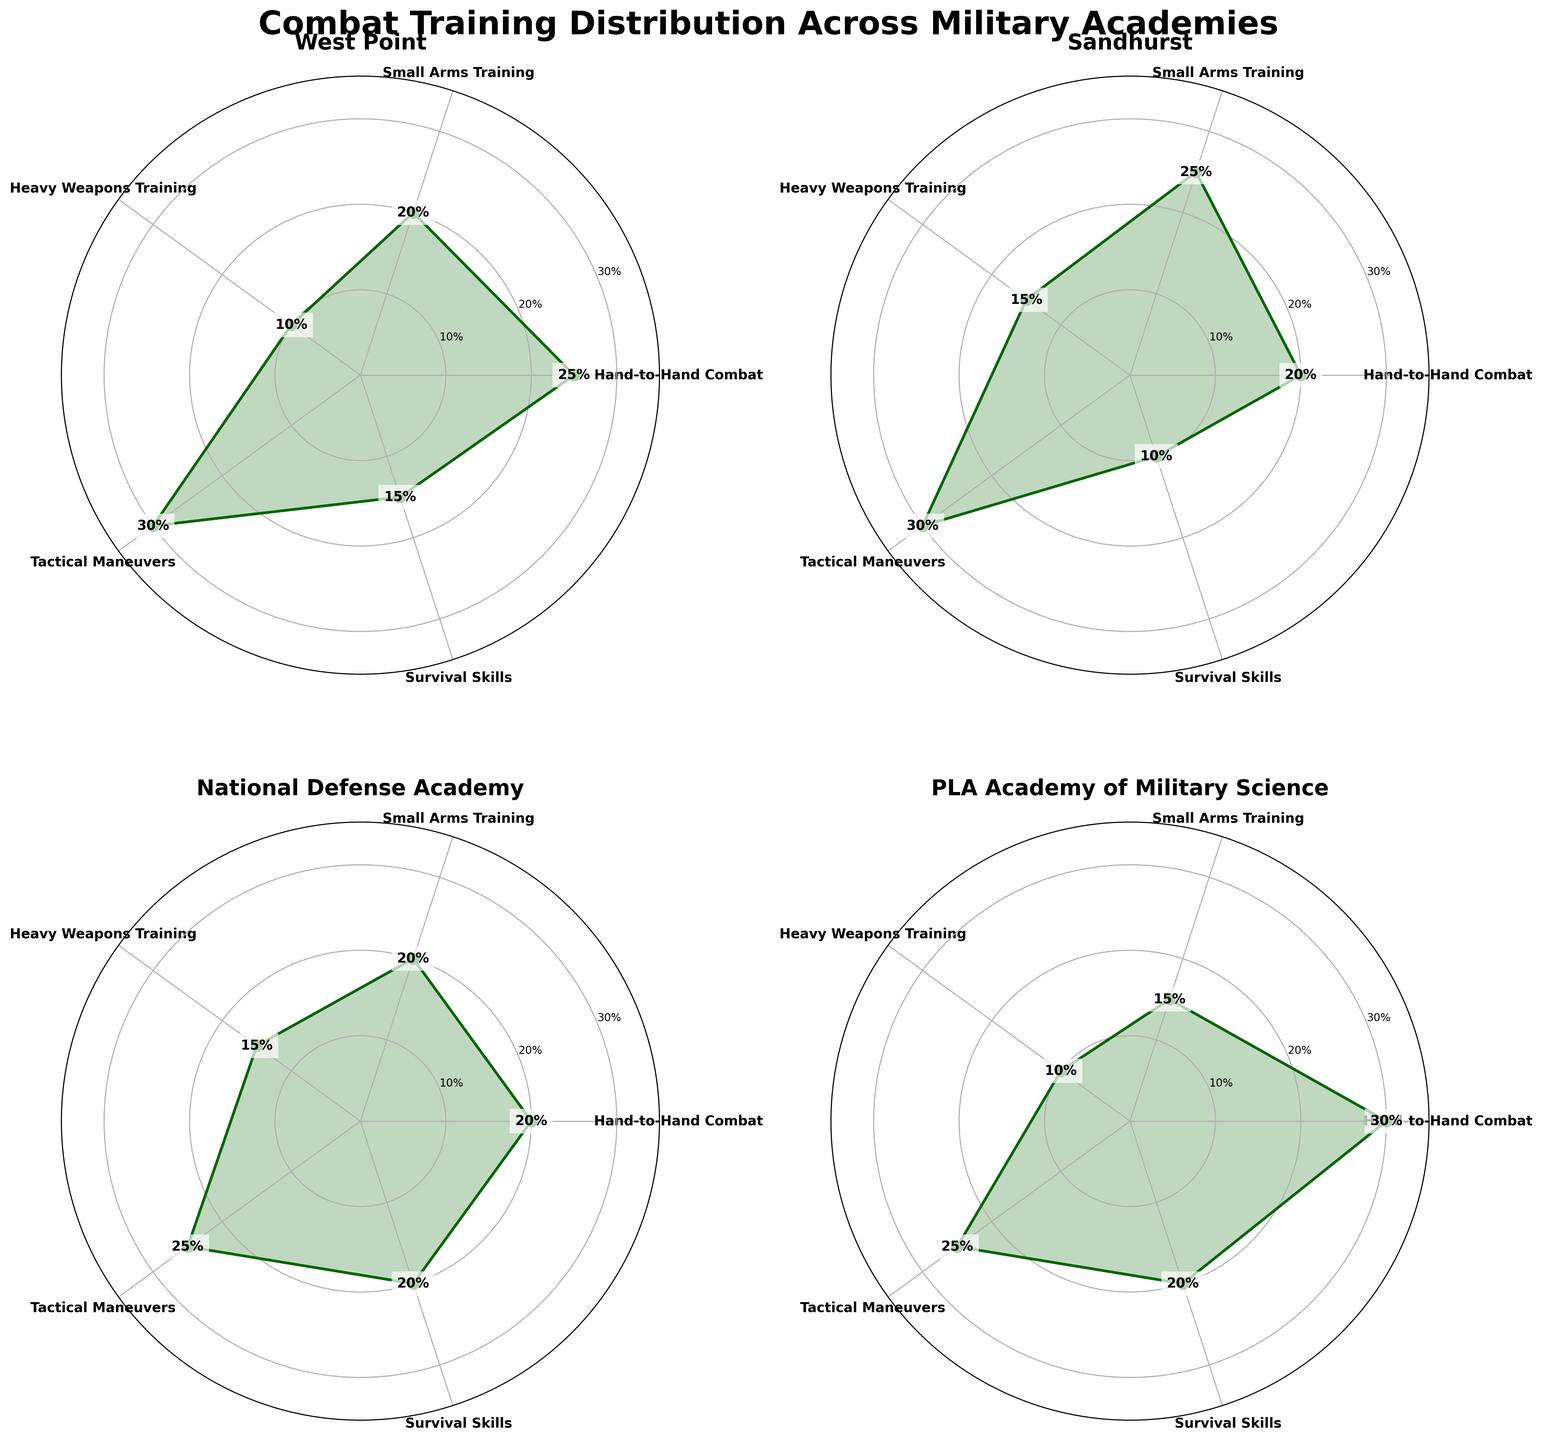What is the title of the figure? The title of the figure is shown prominently at the top and serves as a description of the plot. It reads "Combat Training Distribution Across Military Academies."
Answer: Combat Training Distribution Across Military Academies Which technique has the highest training hours at West Point? By examining the rose chart subplot for West Point, the technique with the largest section and highest value is "Tactical Maneuvers" with 30%.
Answer: Tactical Maneuvers How does the training percentage for Hand-to-Hand Combat at Sandhurst compare to West Point? For Sandhurst, Hand-to-Hand Combat accounts for 20% of training, while at West Point, it is 25%. Hence, Sandhurst dedicates 5% less training hours to Hand-to-Hand Combat compared to West Point.
Answer: Sandhurst has 5% less training Which academy allocates the most training hours to Survival Skills? By comparing the percentages across all subplots for Survival Skills, both National Defense Academy and PLA Academy of Military Science allocate 20% to Survival Skills, which is the maximum.
Answer: National Defense Academy and PLA Academy of Military Science What is the average training hours dedicated to Heavy Weapons Training across all academies? The training hours for Heavy Weapons Training are 10% (West Point), 15% (Sandhurst), 15% (National Defense Academy), and 10% (PLA Academy of Military Science). The average is calculated as (10 + 15 + 15 + 10) / 4 = 12.5%.
Answer: 12.5% Which academy has the least variation in training hours allocated across all techniques? To determine this, we assess the spread of the percentages across all techniques for each academy. National Defense Academy has relatively balanced training hours across techniques with values of 20%, 20%, 15%, 25%, and 20%.
Answer: National Defense Academy In which academy is Hand-to-Hand Combat training emphasized the most? By comparing the Hand-to-Hand Combat training hours across all subplots, the PLA Academy of Military Science allocates the highest with 30%.
Answer: PLA Academy of Military Science What is the total percentage of training hours dedicated to Tactical Maneuvers at West Point and National Defense Academy combined? At West Point, Tactical Maneuvers account for 30%, while at the National Defense Academy, it is 25%. The total percentage is 30% + 25% = 55%.
Answer: 55% Which technique has similar training hours across Sandhurst and National Defense Academy? By comparing values across both academies, Small Arms Training has similar percentages: 25% at Sandhurst and 20% at National Defense Academy.
Answer: Small Arms Training Which military academy focuses least on Heavy Weapons Training? By observing the percentages in the Heavy Weapons Training category, West Point and PLA Academy of Military Science both have the lowest percentage, at 10%.
Answer: West Point and PLA Academy of Military Science 